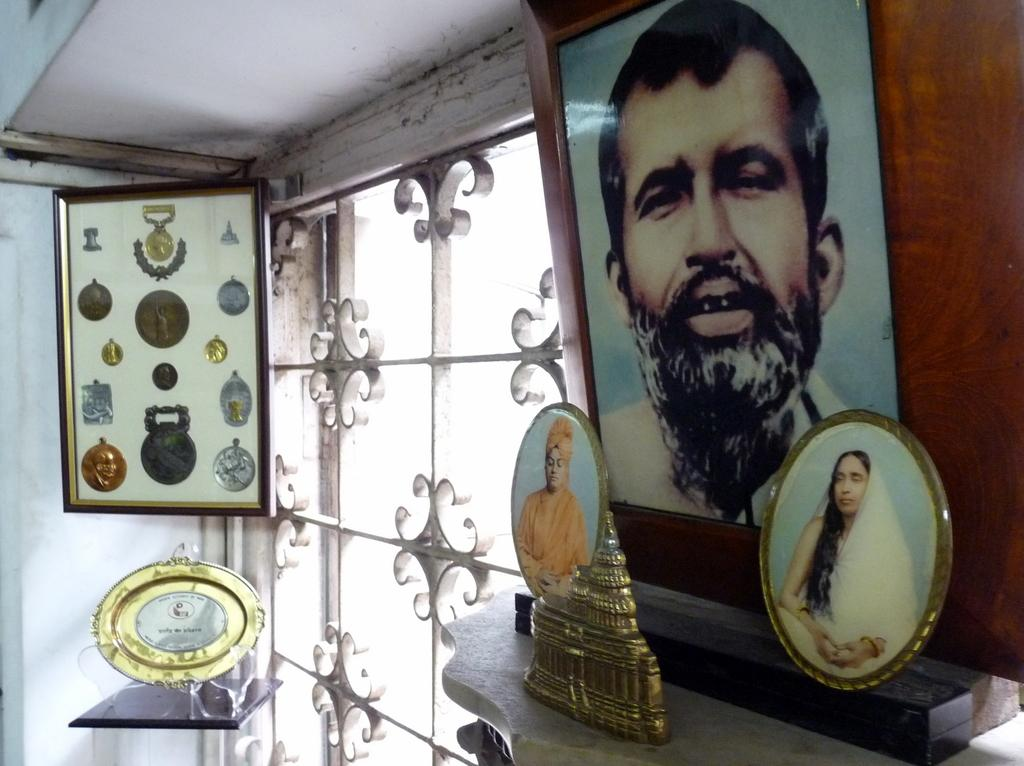What is present on the surface in the image? There are frames on the surface. Where else can frames be found in the image? Frames can also be found on the walls and on a table. What is a feature of the room that allows natural light to enter? There is a window in the image. What type of clouds can be seen outside the window in the image? There are no clouds visible in the image, as the focus is on the frames and the window does not show any outdoor scenery. 